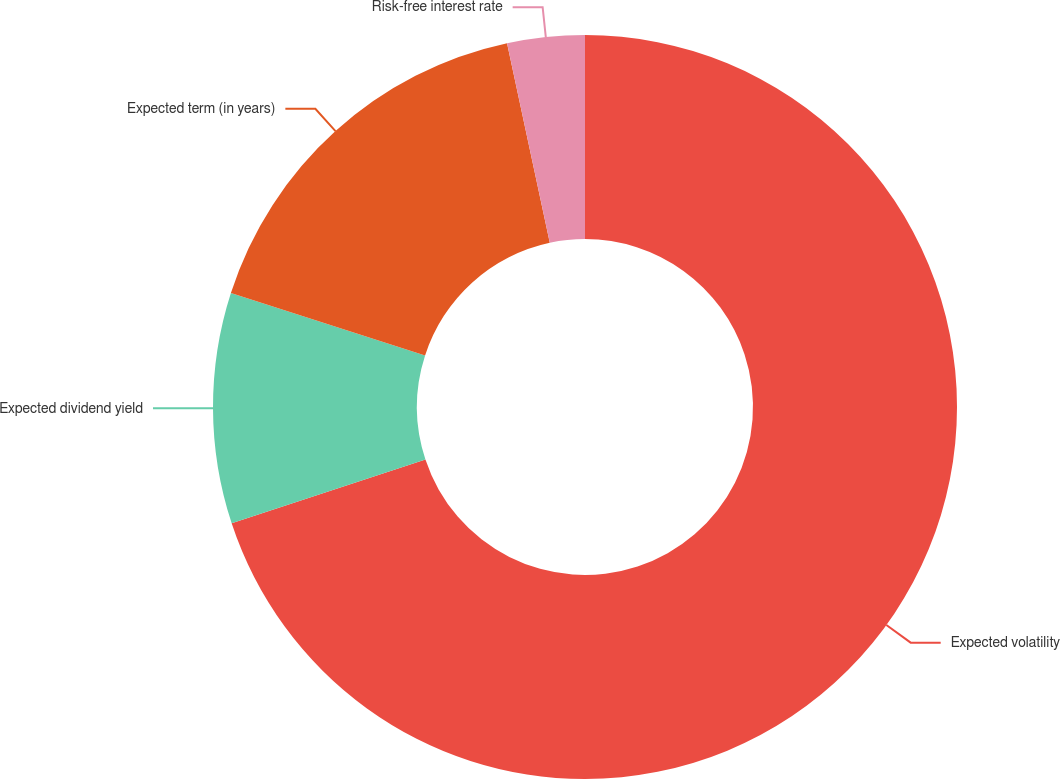Convert chart. <chart><loc_0><loc_0><loc_500><loc_500><pie_chart><fcel>Expected volatility<fcel>Expected dividend yield<fcel>Expected term (in years)<fcel>Risk-free interest rate<nl><fcel>69.93%<fcel>10.02%<fcel>16.68%<fcel>3.36%<nl></chart> 